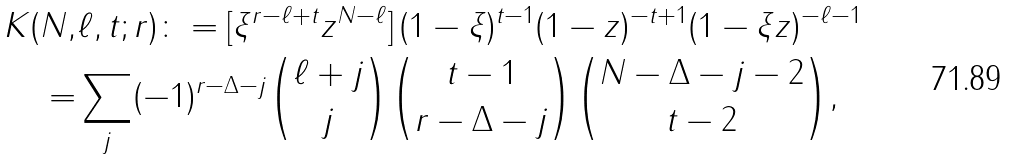<formula> <loc_0><loc_0><loc_500><loc_500>K ( N , & \ell , t ; r ) \colon = [ \xi ^ { r - \ell + t } z ^ { N - \ell } ] \, ( 1 - \xi ) ^ { t - 1 } ( 1 - z ) ^ { - t + 1 } ( 1 - \xi z ) ^ { - \ell - 1 } \\ = & \sum _ { j } ( - 1 ) ^ { r - \Delta - j } \binom { \ell + j } { j } \binom { t - 1 } { r - \Delta - j } \binom { N - \Delta - j - 2 } { t - 2 } ,</formula> 